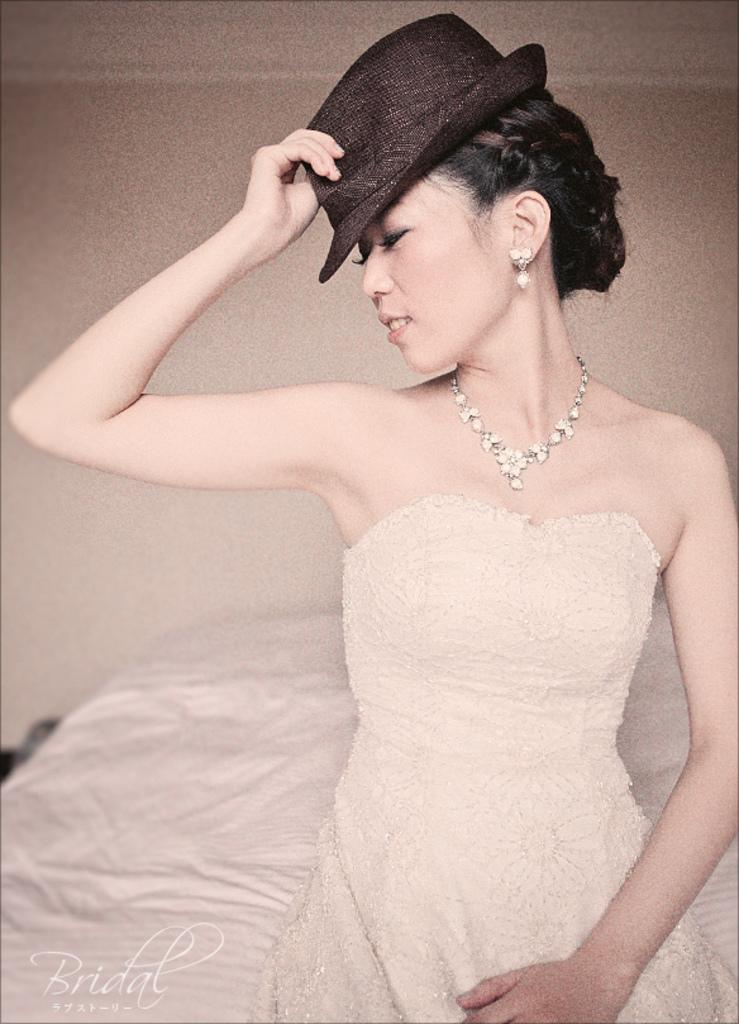Who is the main subject in the image? There is a lady in the image. What is the lady wearing? The lady is wearing a white gown and a cap. What can be seen in the background of the image? There is a wall and a bed in the background of the image. What type of guitar is the lady playing in the image? There is no guitar present in the image; the lady is not playing any musical instrument. 